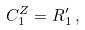Convert formula to latex. <formula><loc_0><loc_0><loc_500><loc_500>C ^ { Z } _ { 1 } = R ^ { \prime } _ { 1 } \, ,</formula> 